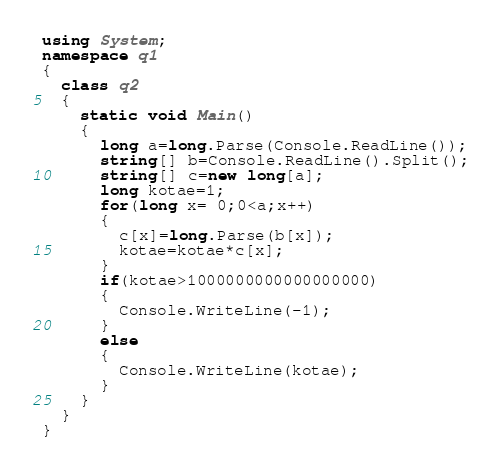Convert code to text. <code><loc_0><loc_0><loc_500><loc_500><_C#_>using System;
namespace q1
{
  class q2
  {
    static void Main()
    {
      long a=long.Parse(Console.ReadLine());
      string[] b=Console.ReadLine().Split();
      string[] c=new long[a];
      long kotae=1;
      for(long x= 0;0<a;x++)
      {
        c[x]=long.Parse(b[x]);
        kotae=kotae*c[x];
      }
      if(kotae>1000000000000000000)
      {
        Console.WriteLine(-1);
      }
      else
      {
        Console.WriteLine(kotae);
      }
    }
  }
}
</code> 